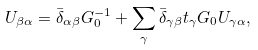<formula> <loc_0><loc_0><loc_500><loc_500>U _ { \beta \alpha } = \bar { \delta } _ { \alpha \beta } G ^ { - 1 } _ { 0 } + \sum _ { \gamma } \bar { \delta } _ { \gamma \beta } t _ { \gamma } G _ { 0 } U _ { \gamma \alpha } ,</formula> 